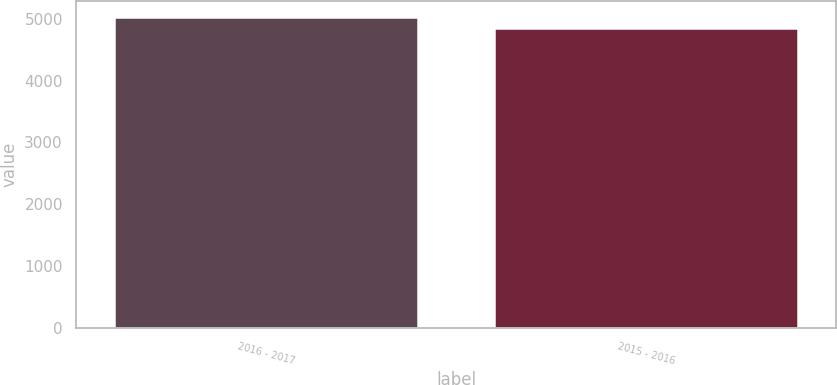Convert chart to OTSL. <chart><loc_0><loc_0><loc_500><loc_500><bar_chart><fcel>2016 - 2017<fcel>2015 - 2016<nl><fcel>5035.1<fcel>4854.8<nl></chart> 